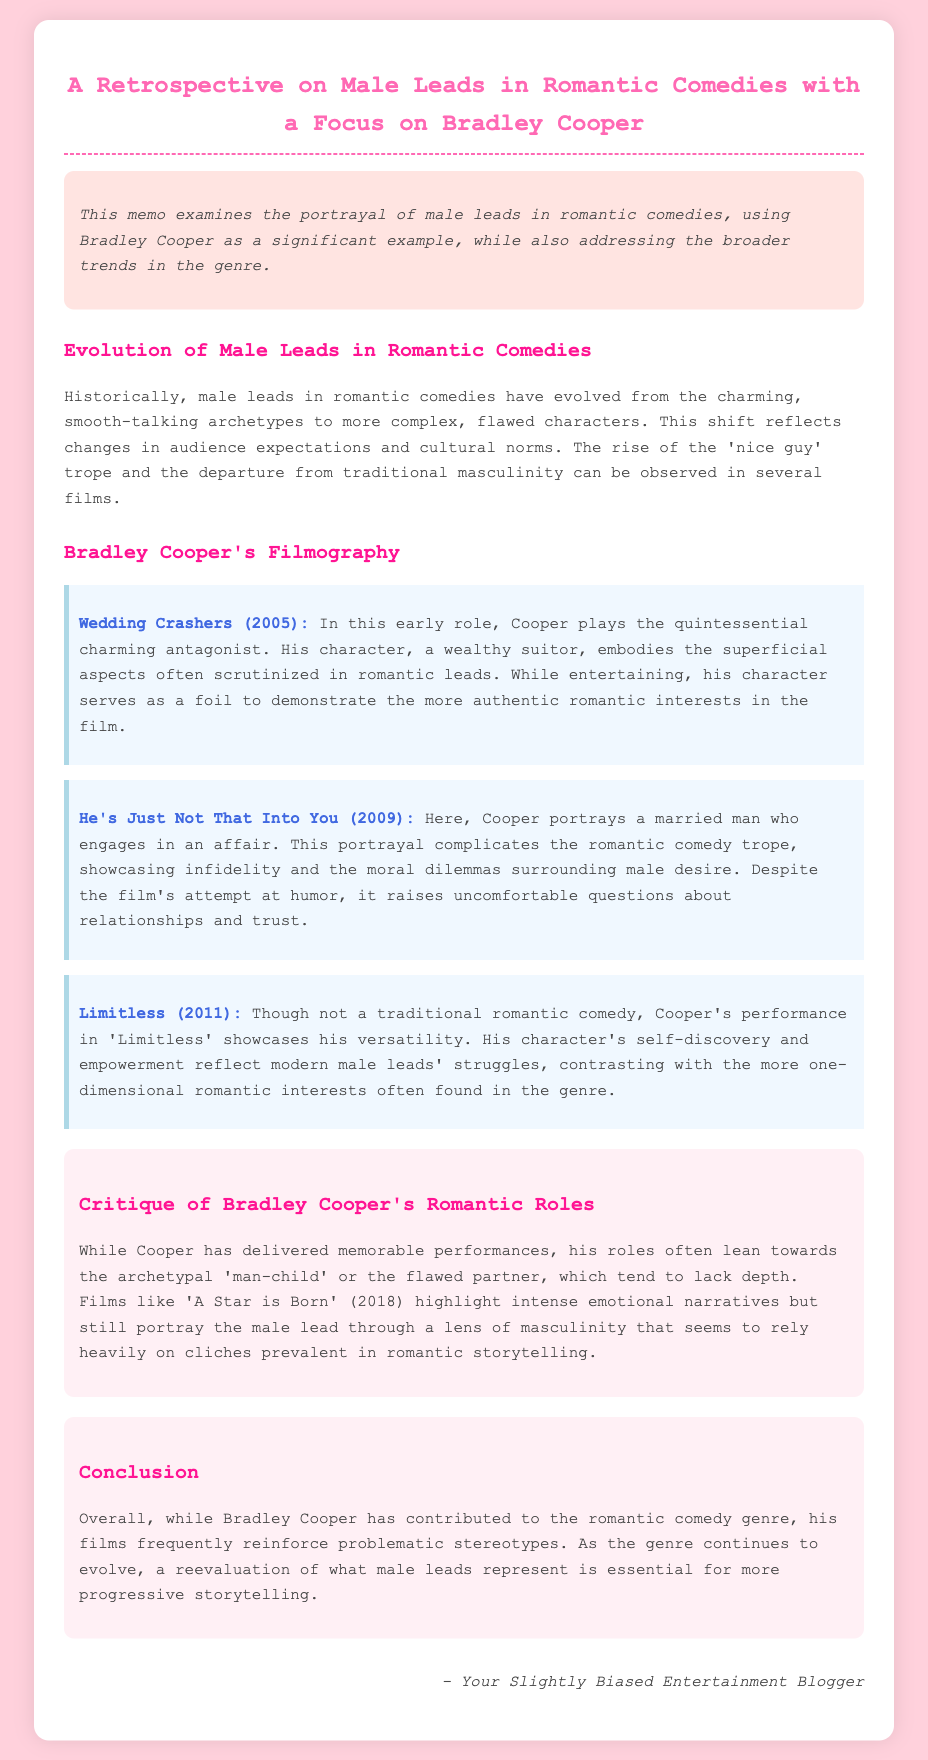what is the title of the memo? The title of the memo is prominently displayed at the top of the document.
Answer: A Retrospective on Male Leads in Romantic Comedies with a Focus on Bradley Cooper what year was 'Wedding Crashers' released? The release year of 'Wedding Crashers' is found in the film section of the document.
Answer: 2005 which character does Bradley Cooper portray in 'He's Just Not That Into You'? The document specifies his role in this film to provide an example of his character type.
Answer: a married man what is a theme discussed in 'Limitless'? The memo presents the character's qualities in 'Limitless' to illustrate a broader theme relevant to male leads.
Answer: self-discovery how does the memo characterize Cooper's typical roles? The critique section of the document describes the nature of his characters in romantic comedies.
Answer: 'man-child' what does the memo suggest about the evolution of male leads? This is mentioned in the introduction and reflects changes in the genre over time.
Answer: more complex, flawed characters what is the concluding remark regarding Cooper's contributions? The conclusion summarizes the overall sentiment toward Cooper's roles in the genre.
Answer: problematic stereotypes in which film does Bradley Cooper's character exemplify emotional narratives? The critique points out a specific film illustrating the emotional aspect of his roles.
Answer: A Star is Born what is the focus of the memo? The introduction of the memo outlines its primary area of examination.
Answer: portrayal of male leads in romantic comedies 